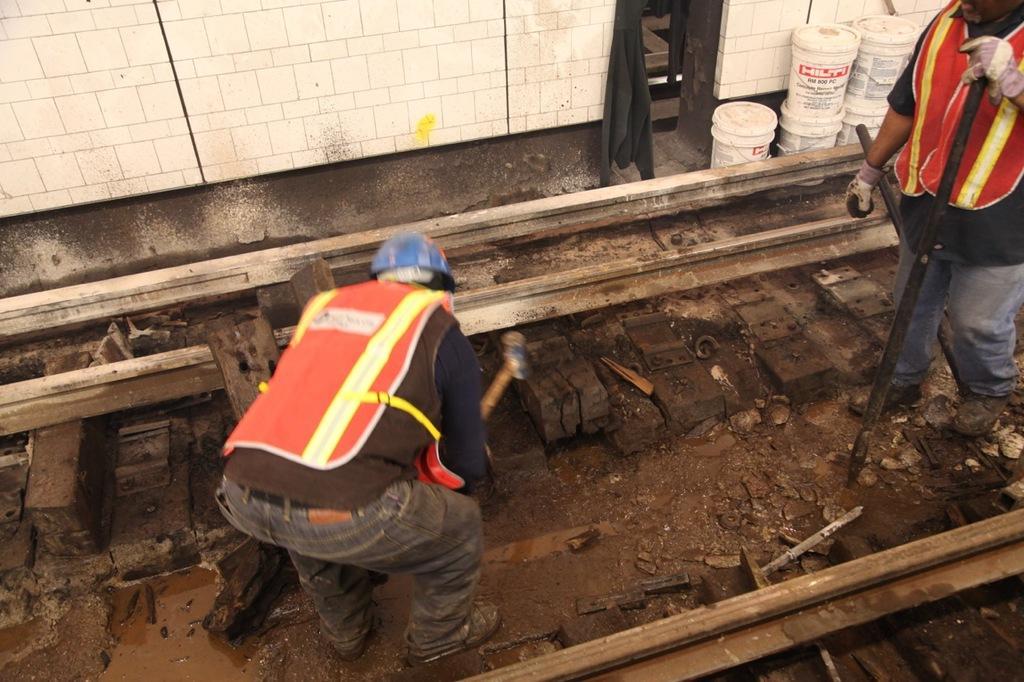In one or two sentences, can you explain what this image depicts? There are two persons wearing helmet, gloves and jacket. They are working. Person on the right is holding a rod. In the back there are buckets and a wall. Also there are some iron rods and water on the ground. And there are some other things on the ground. 